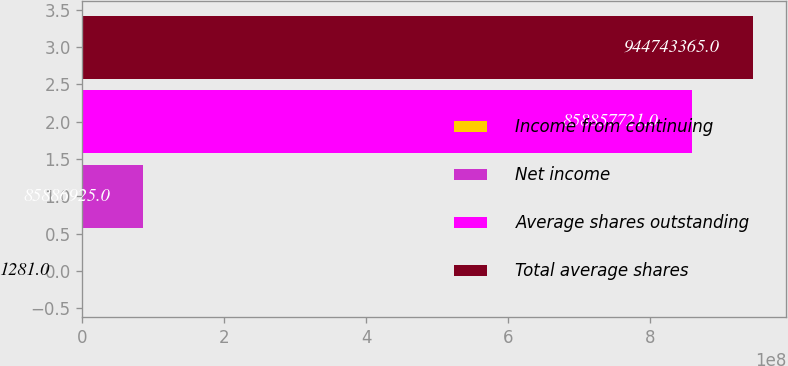Convert chart to OTSL. <chart><loc_0><loc_0><loc_500><loc_500><bar_chart><fcel>Income from continuing<fcel>Net income<fcel>Average shares outstanding<fcel>Total average shares<nl><fcel>1281<fcel>8.58869e+07<fcel>8.58858e+08<fcel>9.44743e+08<nl></chart> 